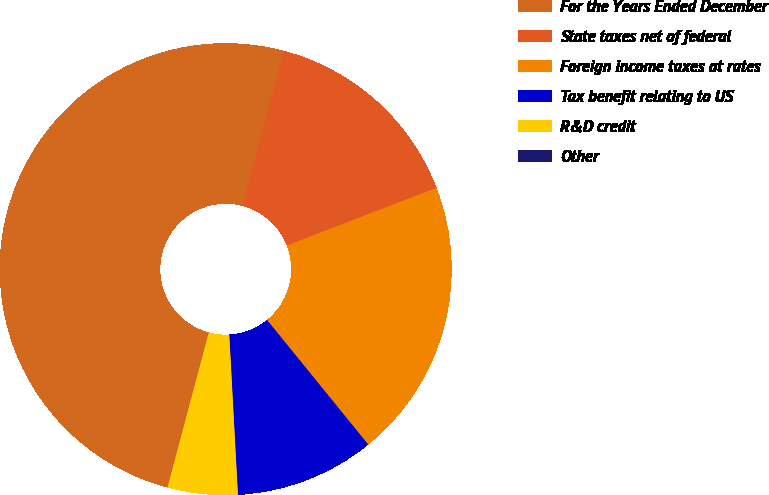Convert chart. <chart><loc_0><loc_0><loc_500><loc_500><pie_chart><fcel>For the Years Ended December<fcel>State taxes net of federal<fcel>Foreign income taxes at rates<fcel>Tax benefit relating to US<fcel>R&D credit<fcel>Other<nl><fcel>49.99%<fcel>15.0%<fcel>20.0%<fcel>10.0%<fcel>5.0%<fcel>0.0%<nl></chart> 